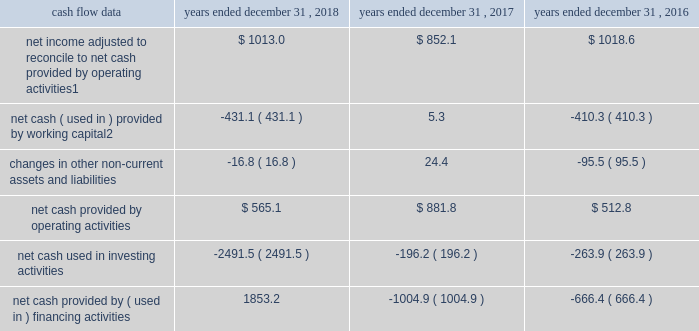Management 2019s discussion and analysis of financial condition and results of operations 2013 ( continued ) ( amounts in millions , except per share amounts ) liquidity and capital resources cash flow overview the tables summarize key financial data relating to our liquidity , capital resources and uses of capital. .
1 reflects net income adjusted primarily for depreciation and amortization of fixed assets and intangible assets , amortization of restricted stock and other non-cash compensation , net losses on sales of businesses and deferred income taxes .
2 reflects changes in accounts receivable , accounts receivable billable to clients , other current assets , accounts payable and accrued liabilities .
Operating activities due to the seasonality of our business , we typically use cash from working capital in the first nine months of a year , with the largest impact in the first quarter , and generate cash from working capital in the fourth quarter , driven by the seasonally strong media spending by our clients .
Quarterly and annual working capital results are impacted by the fluctuating annual media spending budgets of our clients as well as their changing media spending patterns throughout each year across various countries .
The timing of media buying on behalf of our clients across various countries affects our working capital and operating cash flow and can be volatile .
In most of our businesses , our agencies enter into commitments to pay production and media costs on behalf of clients .
To the extent possible , we pay production and media charges after we have received funds from our clients .
The amounts involved , which substantially exceed our revenues , primarily affect the level of accounts receivable , accounts payable , accrued liabilities and contract liabilities .
Our assets include both cash received and accounts receivable from clients for these pass-through arrangements , while our liabilities include amounts owed on behalf of clients to media and production suppliers .
Our accrued liabilities are also affected by the timing of certain other payments .
For example , while annual cash incentive awards are accrued throughout the year , they are generally paid during the first quarter of the subsequent year .
Net cash provided by operating activities during 2018 was $ 565.1 , which was a decrease of $ 316.7 as compared to 2017 , primarily as a result of an increase in working capital usage of $ 436.4 .
Working capital in 2018 was impacted by the spending levels of our clients as compared to 2017 .
The working capital usage in both periods was primarily attributable to our media businesses .
Net cash provided by operating activities during 2017 was $ 881.8 , which was an increase of $ 369.0 as compared to 2016 , primarily as a result of an improvement in working capital usage of $ 415.6 .
Working capital in 2017 benefited from the spending patterns of our clients compared to 2016 .
Investing activities net cash used in investing activities during 2018 consisted of payments for acquisitions of $ 2309.8 , related mostly to the acxiom acquisition , and payments for capital expenditures of $ 177.1 , related mostly to leasehold improvements and computer hardware and software. .
What is the average of net cash provided by operating activities from 2016 to 2018 , in millions? 
Computations: (((512.8 + 881.8) + 565.1) / 3)
Answer: 653.23333. 